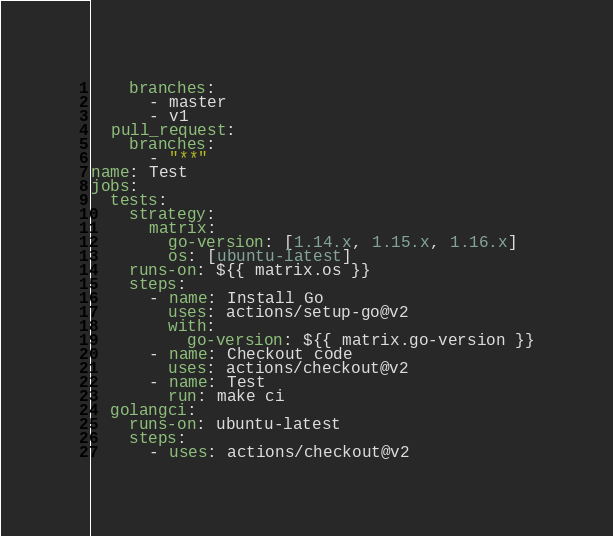Convert code to text. <code><loc_0><loc_0><loc_500><loc_500><_YAML_>    branches:
      - master
      - v1
  pull_request:
    branches:
      - "**"
name: Test
jobs:
  tests:
    strategy:
      matrix:
        go-version: [1.14.x, 1.15.x, 1.16.x]
        os: [ubuntu-latest]
    runs-on: ${{ matrix.os }}
    steps:
      - name: Install Go
        uses: actions/setup-go@v2
        with:
          go-version: ${{ matrix.go-version }}
      - name: Checkout code
        uses: actions/checkout@v2
      - name: Test
        run: make ci
  golangci:
    runs-on: ubuntu-latest
    steps:
      - uses: actions/checkout@v2</code> 